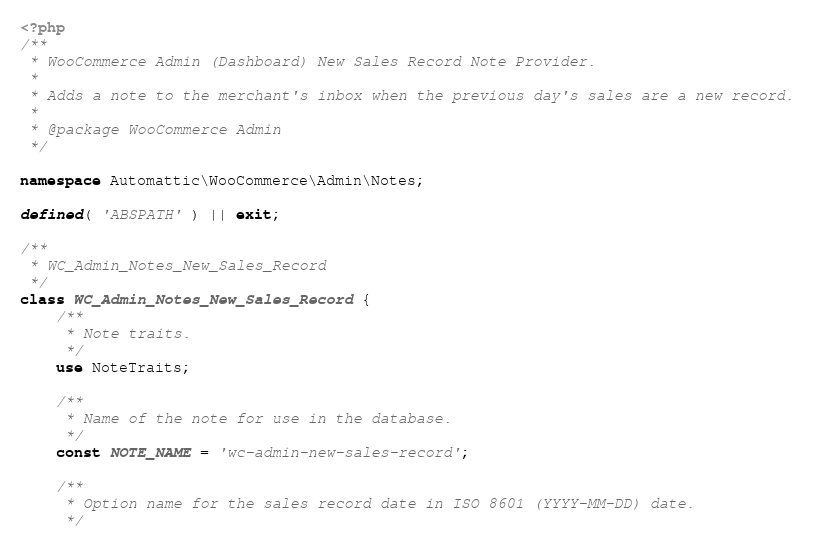<code> <loc_0><loc_0><loc_500><loc_500><_PHP_><?php
/**
 * WooCommerce Admin (Dashboard) New Sales Record Note Provider.
 *
 * Adds a note to the merchant's inbox when the previous day's sales are a new record.
 *
 * @package WooCommerce Admin
 */

namespace Automattic\WooCommerce\Admin\Notes;

defined( 'ABSPATH' ) || exit;

/**
 * WC_Admin_Notes_New_Sales_Record
 */
class WC_Admin_Notes_New_Sales_Record {
	/**
	 * Note traits.
	 */
	use NoteTraits;

	/**
	 * Name of the note for use in the database.
	 */
	const NOTE_NAME = 'wc-admin-new-sales-record';

	/**
	 * Option name for the sales record date in ISO 8601 (YYYY-MM-DD) date.
	 */</code> 